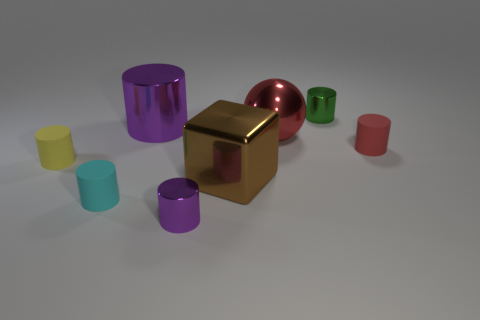Subtract all large shiny cylinders. How many cylinders are left? 5 Add 1 blue spheres. How many objects exist? 9 Subtract all red cylinders. How many cylinders are left? 5 Subtract 3 cylinders. How many cylinders are left? 3 Subtract all cyan cylinders. How many red blocks are left? 0 Subtract all big shiny spheres. Subtract all small yellow cylinders. How many objects are left? 6 Add 5 green metallic cylinders. How many green metallic cylinders are left? 6 Add 6 gray matte objects. How many gray matte objects exist? 6 Subtract 0 green blocks. How many objects are left? 8 Subtract all cylinders. How many objects are left? 2 